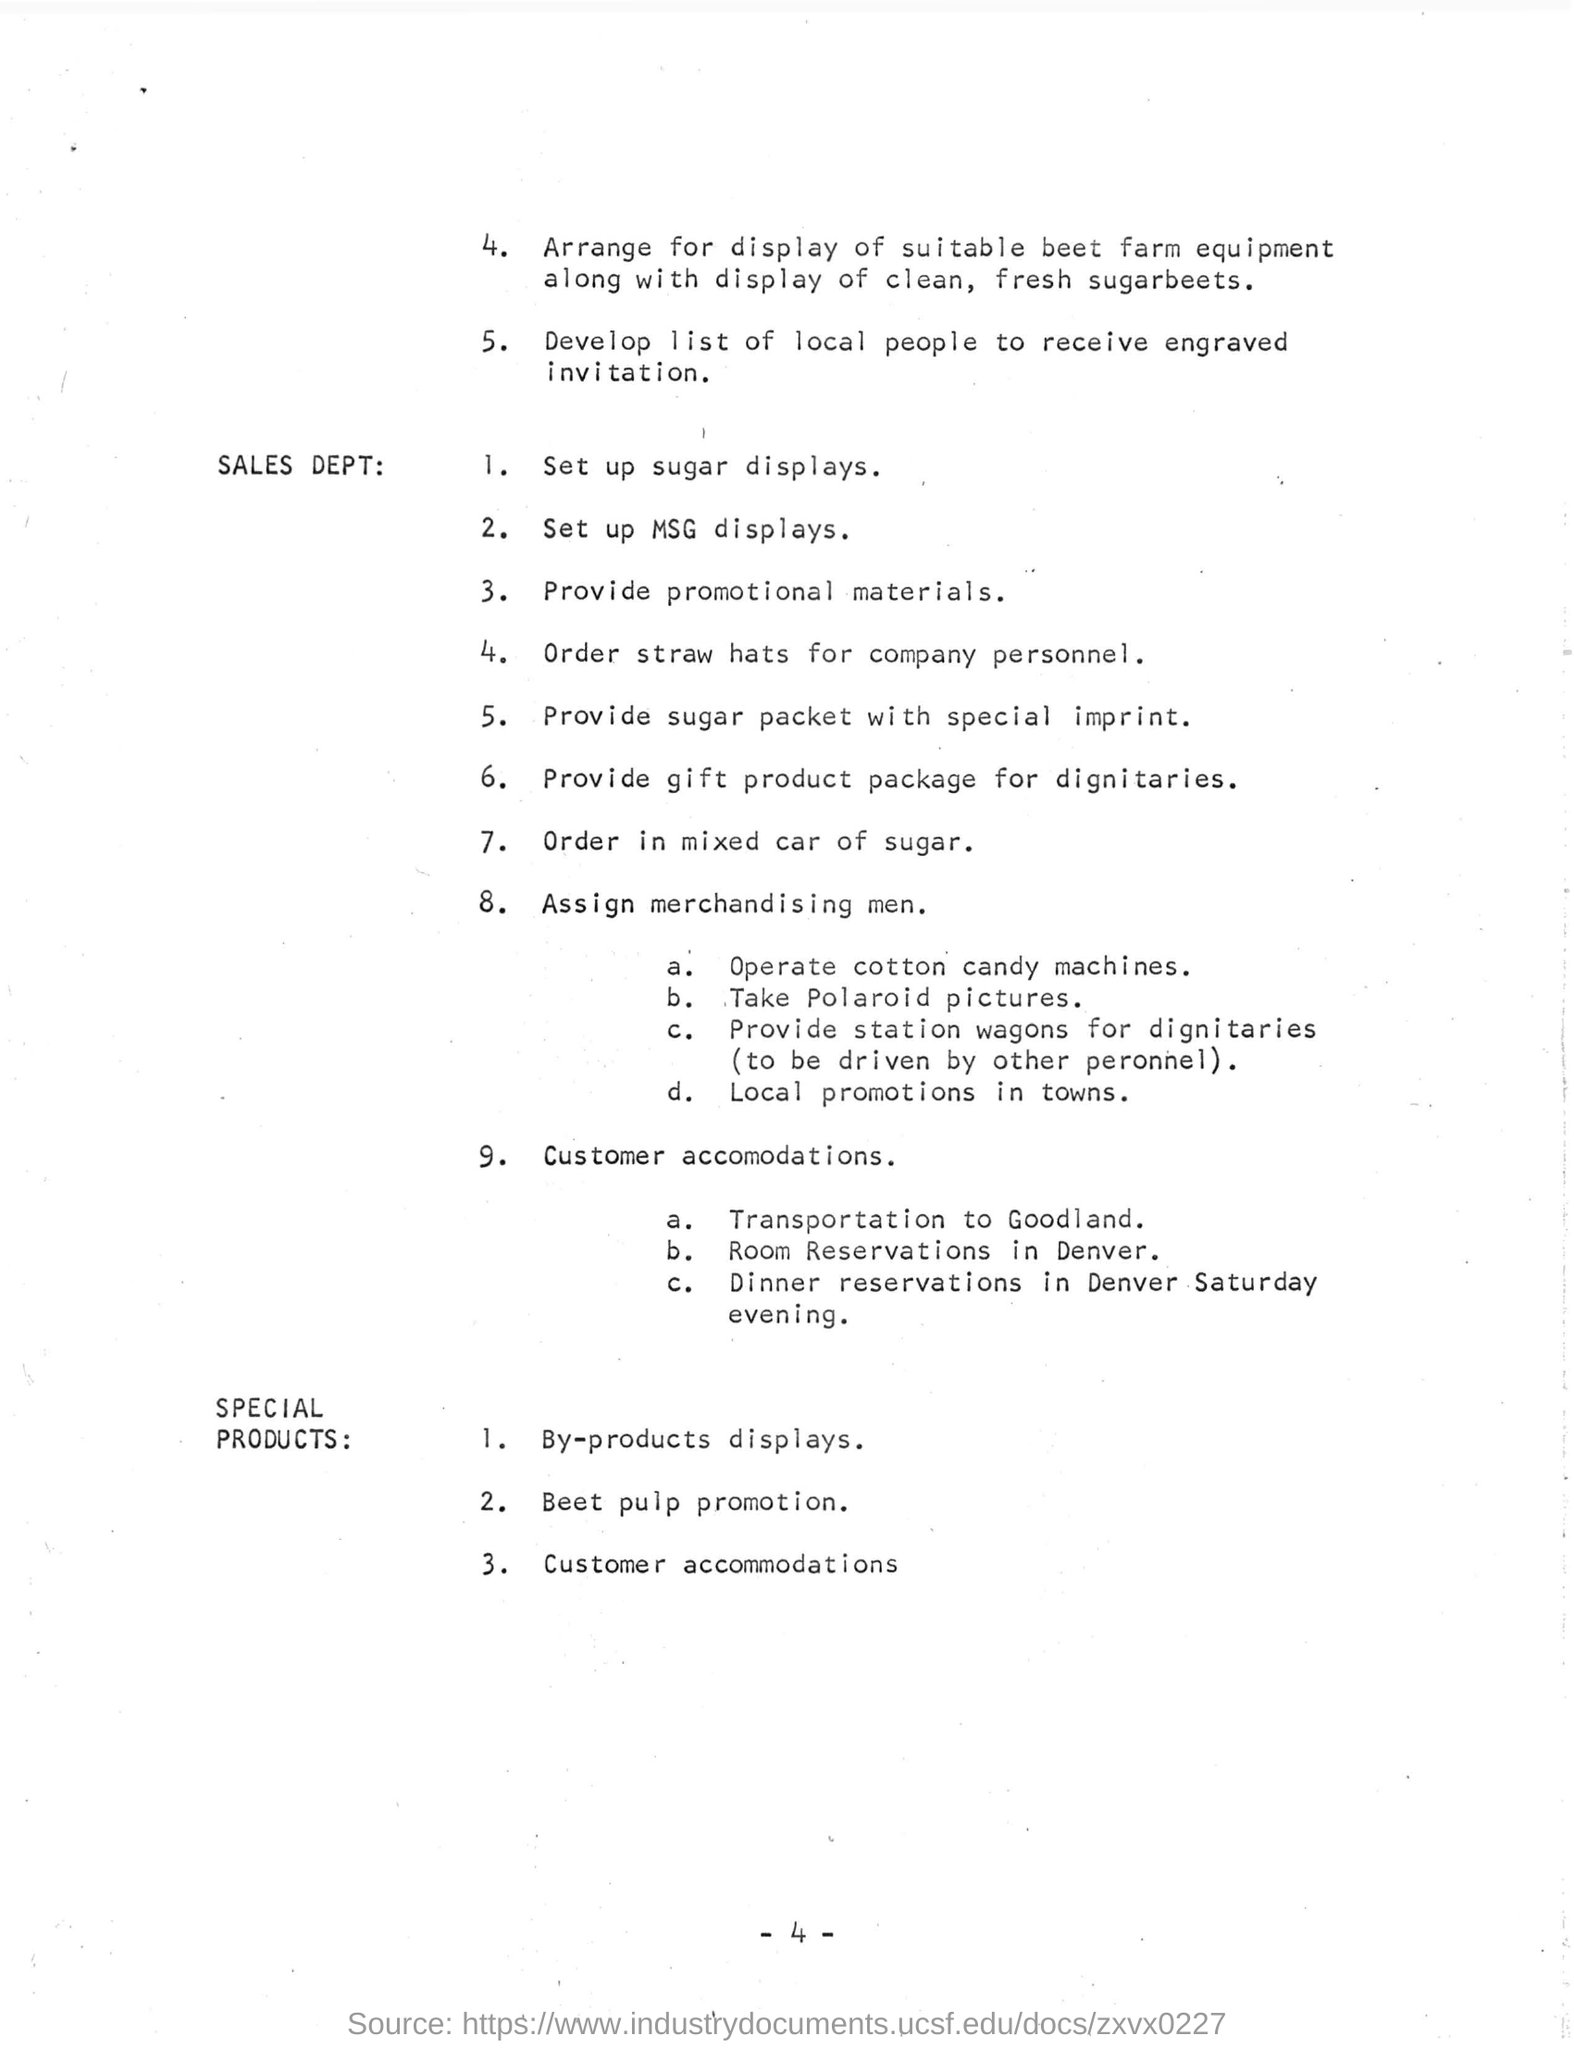Indicate a few pertinent items in this graphic. It is recommended that the company personnel should be ordered straw hats. Room reservation for customers is available in Denver. Dignitaries should be provided with gift product packages. 